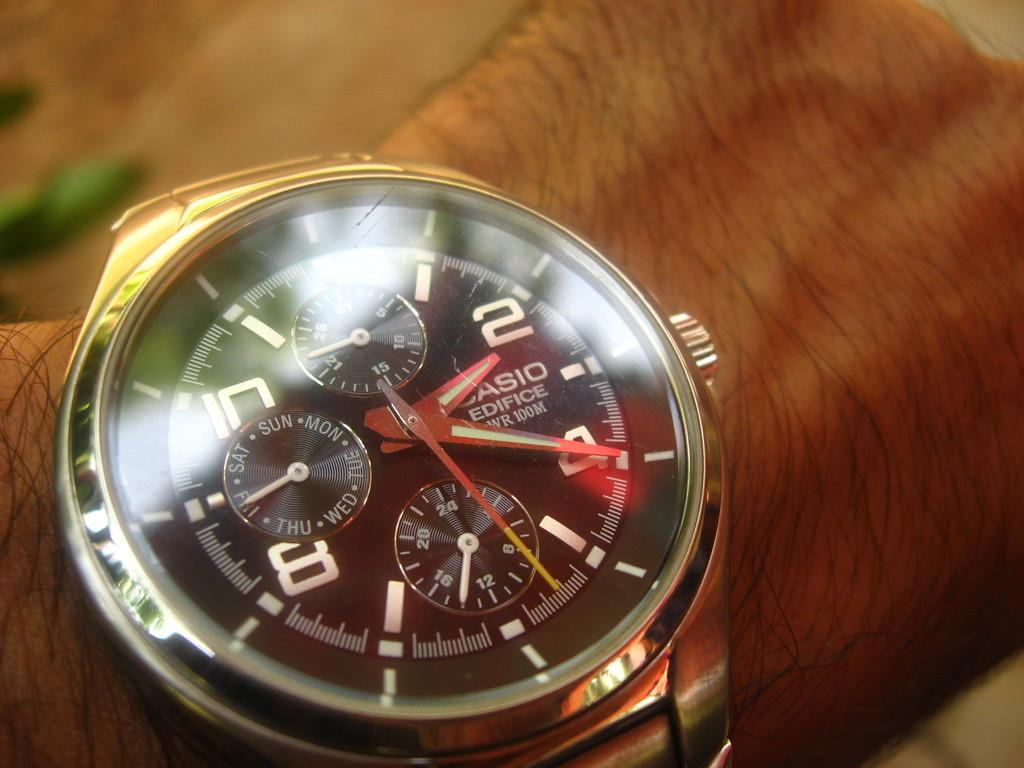<image>
Present a compact description of the photo's key features. A Casio watch with the time of 2:20 on it. 